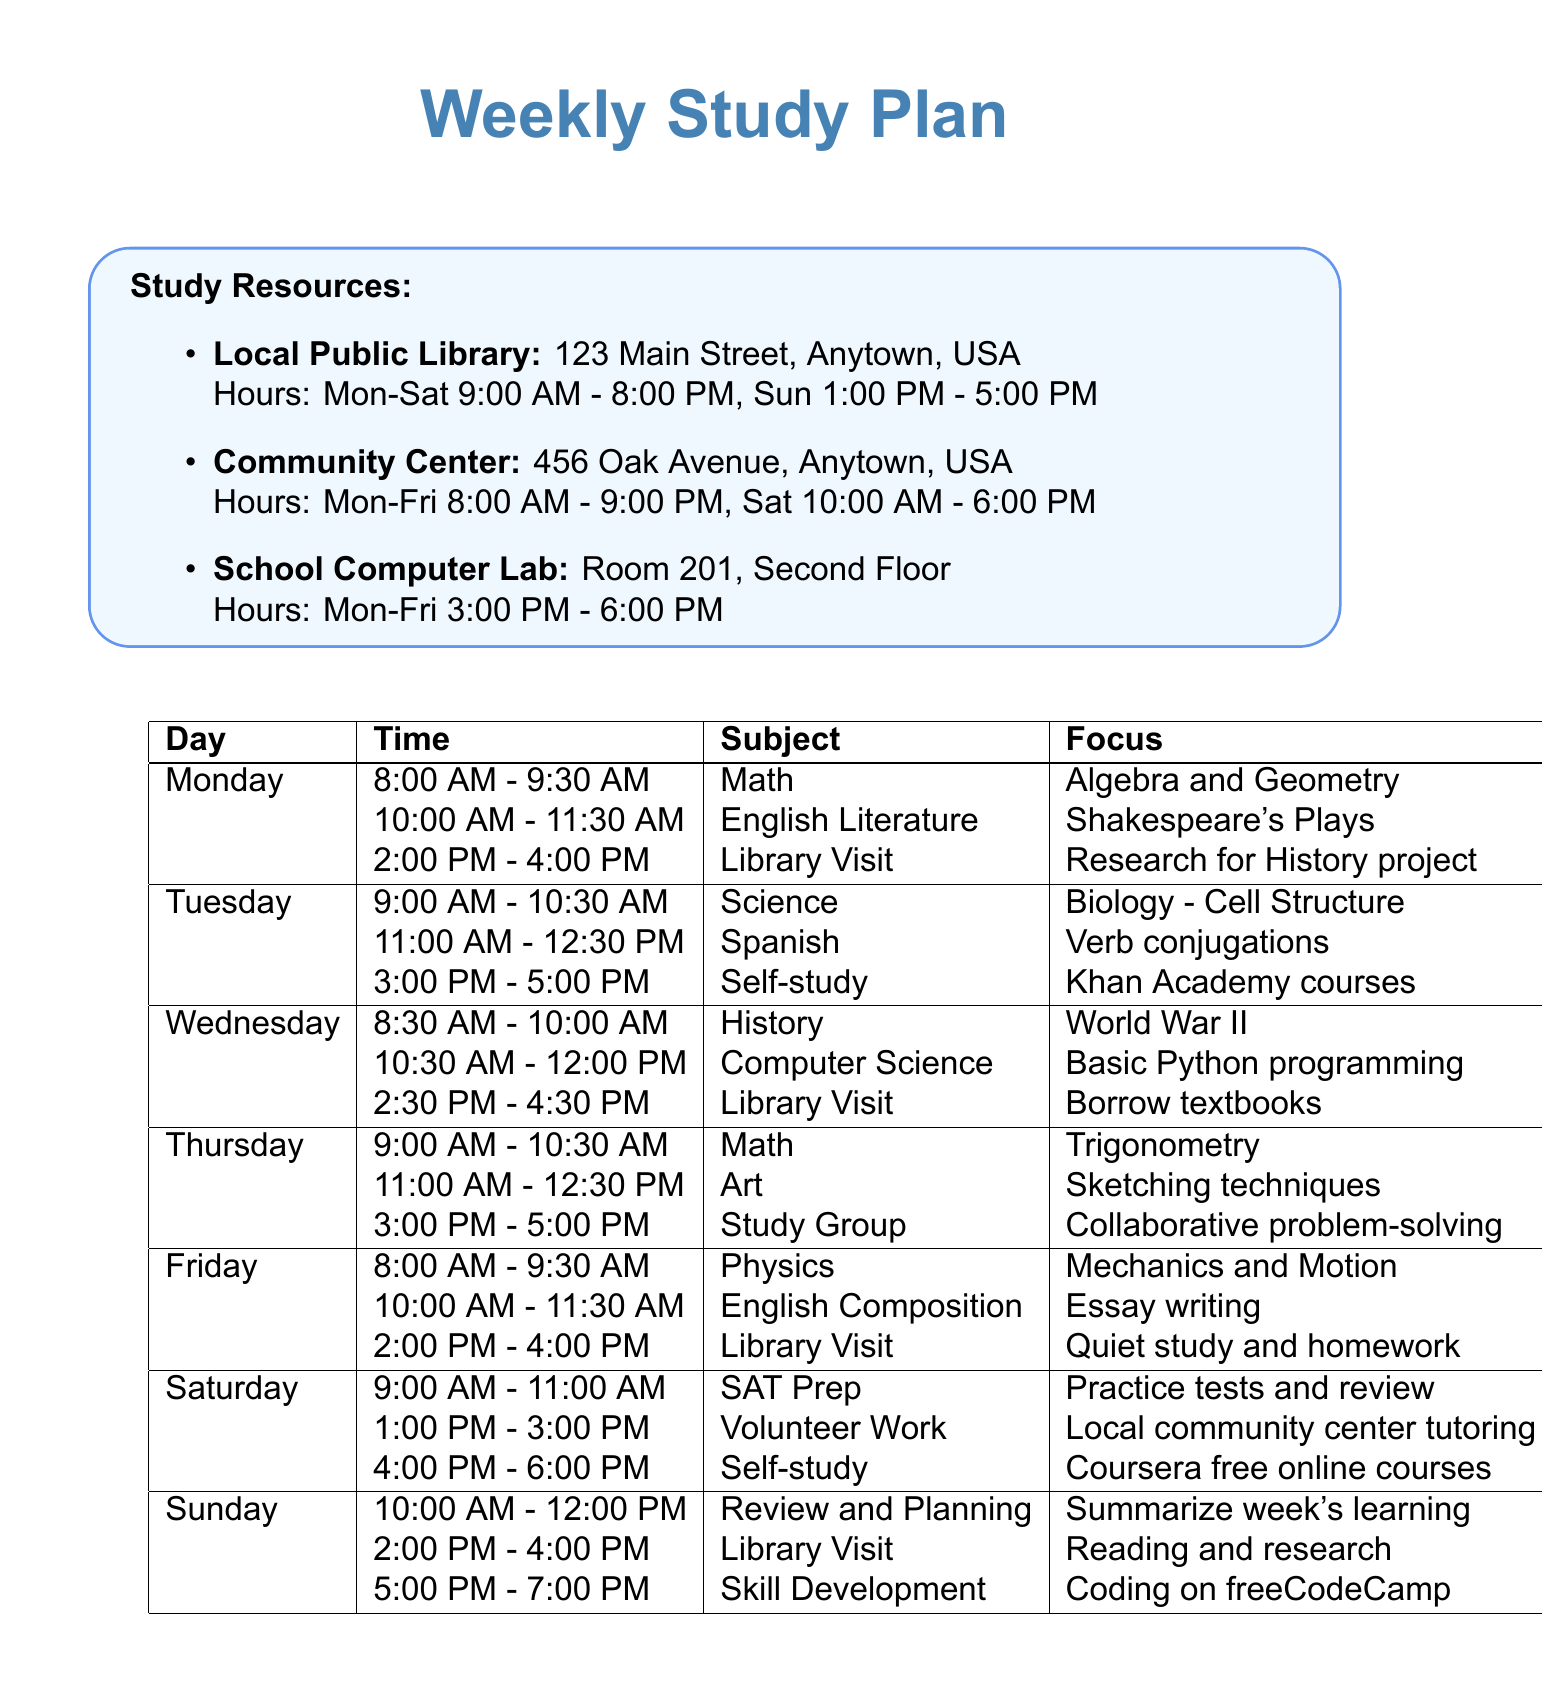What is the focus of the study on Tuesday from 3:00 PM to 5:00 PM? The focus for self-study on Tuesday is Khan Academy online courses during that time.
Answer: Khan Academy online courses What subject is studied on Wednesday at 8:30 AM? The subject studied at 8:30 AM on Wednesday is History, specifically focusing on World War II.
Answer: History How many library visits are scheduled during the week? The document lists three specific instances of library visits throughout the week.
Answer: Three What is the longest study block in terms of hours on Saturday? The study block for SAT Prep on Saturday lasts for two hours, from 9:00 AM to 11:00 AM.
Answer: Two hours Which online resource focuses on coding? Among the online resources listed, freeCodeCamp is the one specifically designed for coding and web development.
Answer: freeCodeCamp During which day do students have study group sessions? Study group sessions are scheduled for Thursday from 3:00 PM to 5:00 PM.
Answer: Thursday What is the time block for English Literature on Monday? The English Literature study block on Monday is from 10:00 AM to 11:30 AM.
Answer: 10:00 AM - 11:30 AM What is the purpose of the library visit on Sunday? The focus for the library visit on Sunday includes reading and research for upcoming projects.
Answer: Reading and research for upcoming projects What subject is taught on Friday at 10:00 AM? The subject being taught at 10:00 AM on Friday is English Composition.
Answer: English Composition 